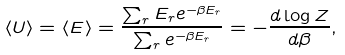Convert formula to latex. <formula><loc_0><loc_0><loc_500><loc_500>\langle U \rangle = \langle E \rangle = \frac { \sum _ { r } E _ { r } e ^ { - \beta E _ { r } } } { \sum _ { r } e ^ { - \beta E _ { r } } } = - \frac { d \log Z } { d \beta } ,</formula> 